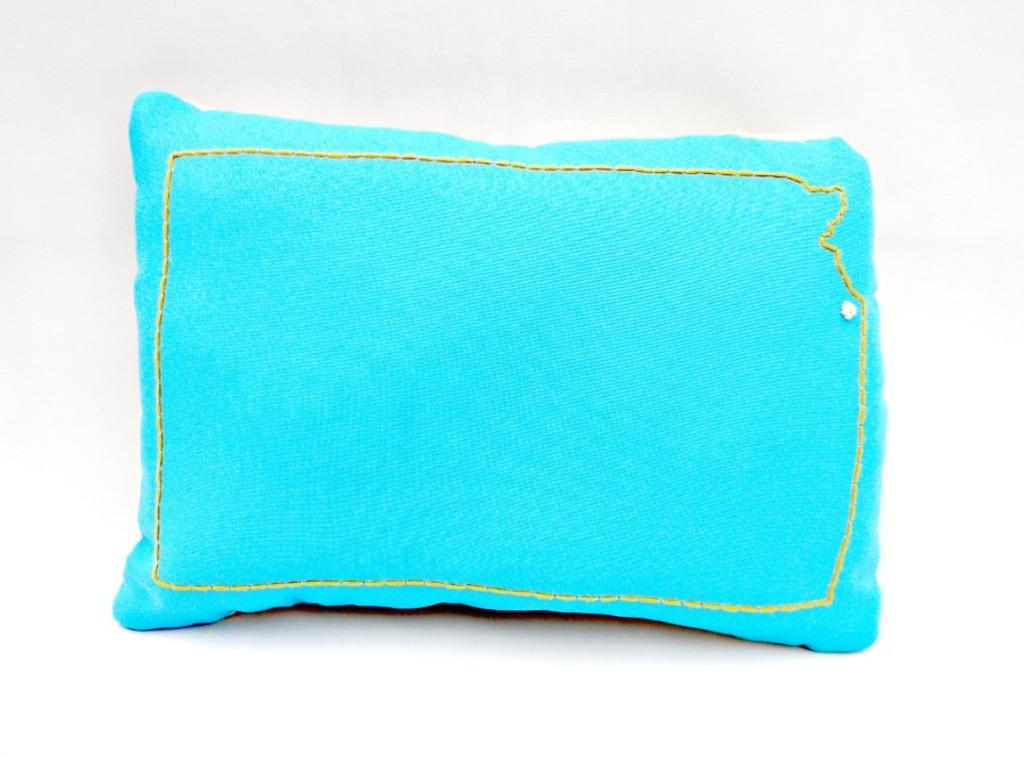What is the main object in the center of the image? There is a pillow in the center of the image. Can you see a car stuck in the quicksand near the hill in the image? There is no car, quicksand, or hill present in the image; it only features a pillow. 